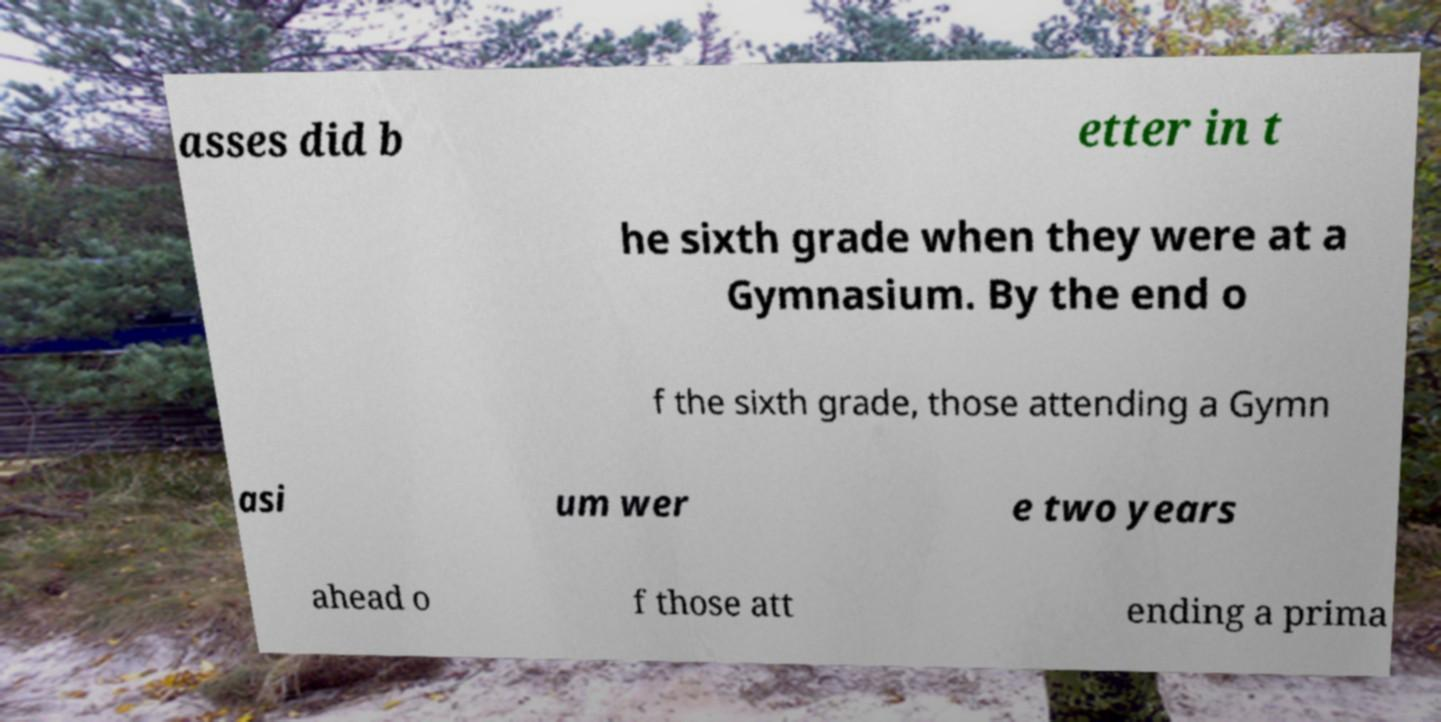I need the written content from this picture converted into text. Can you do that? asses did b etter in t he sixth grade when they were at a Gymnasium. By the end o f the sixth grade, those attending a Gymn asi um wer e two years ahead o f those att ending a prima 